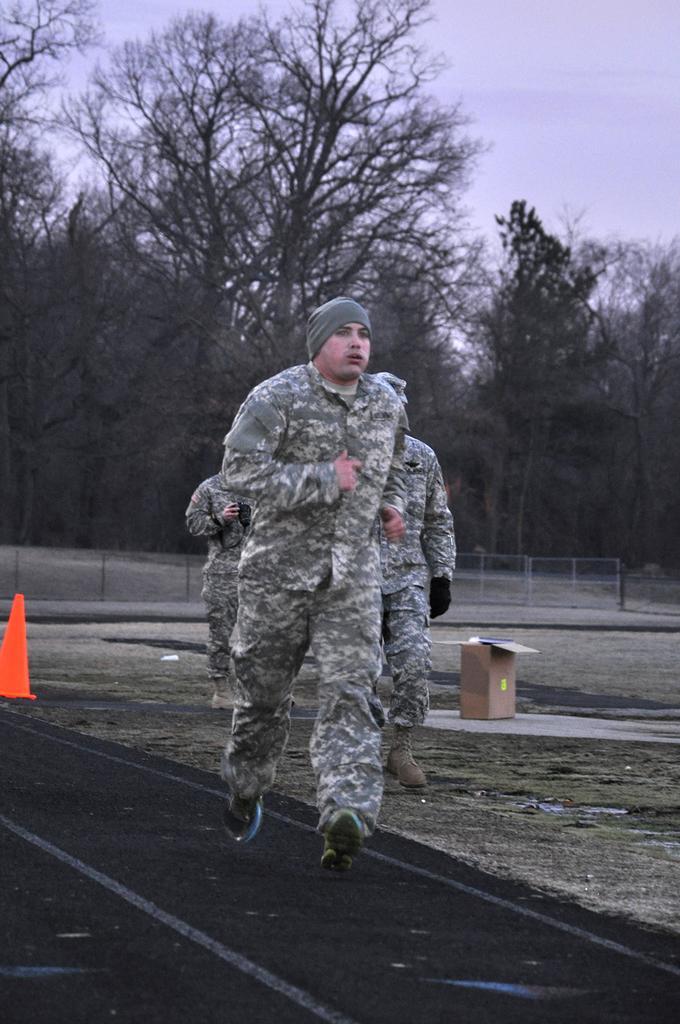Could you give a brief overview of what you see in this image? In this image a man is running on the track. Behind him there are two persons. Here there is a carton. Here is a traffic cone. In the background there are trees, boundary. 